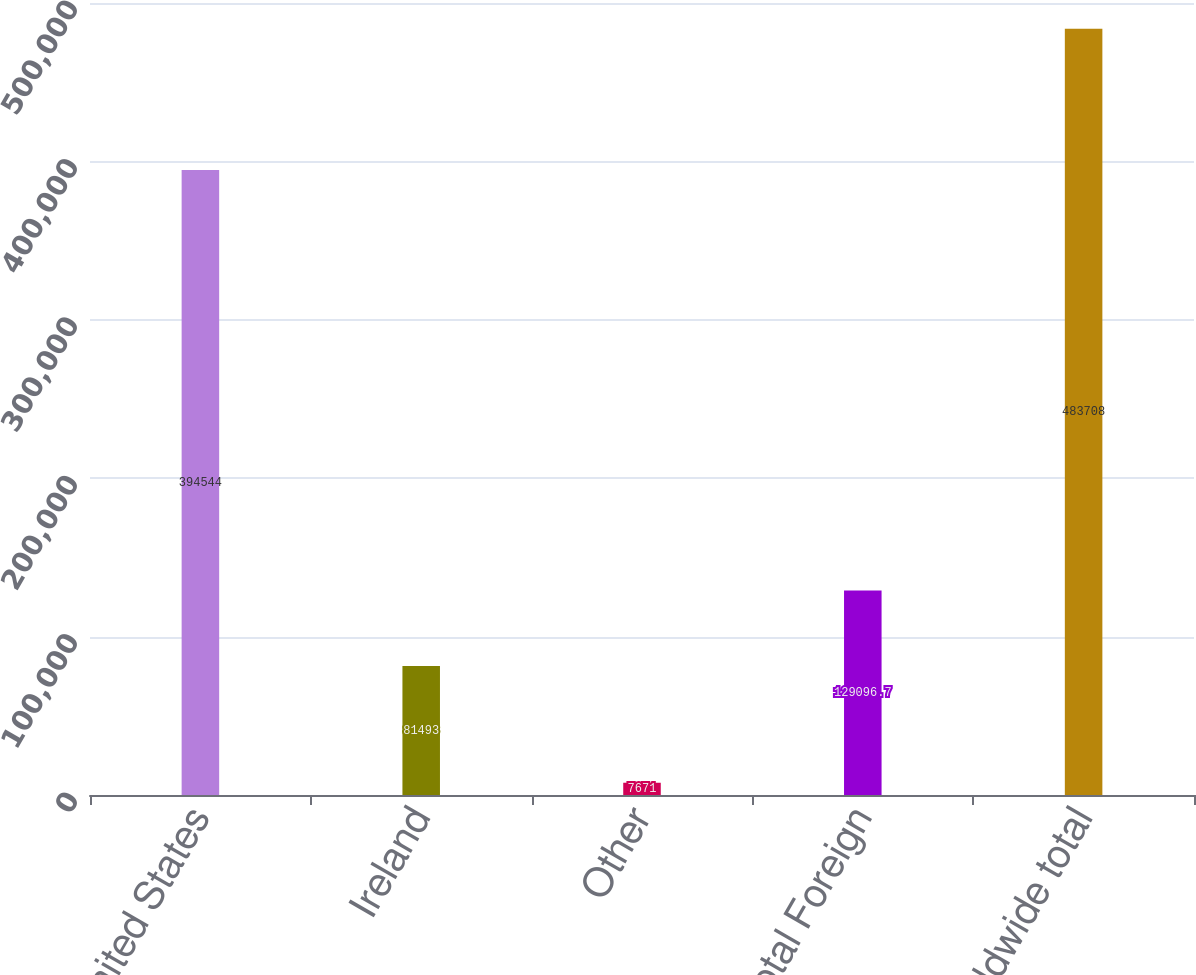<chart> <loc_0><loc_0><loc_500><loc_500><bar_chart><fcel>United States<fcel>Ireland<fcel>Other<fcel>Total Foreign<fcel>Worldwide total<nl><fcel>394544<fcel>81493<fcel>7671<fcel>129097<fcel>483708<nl></chart> 